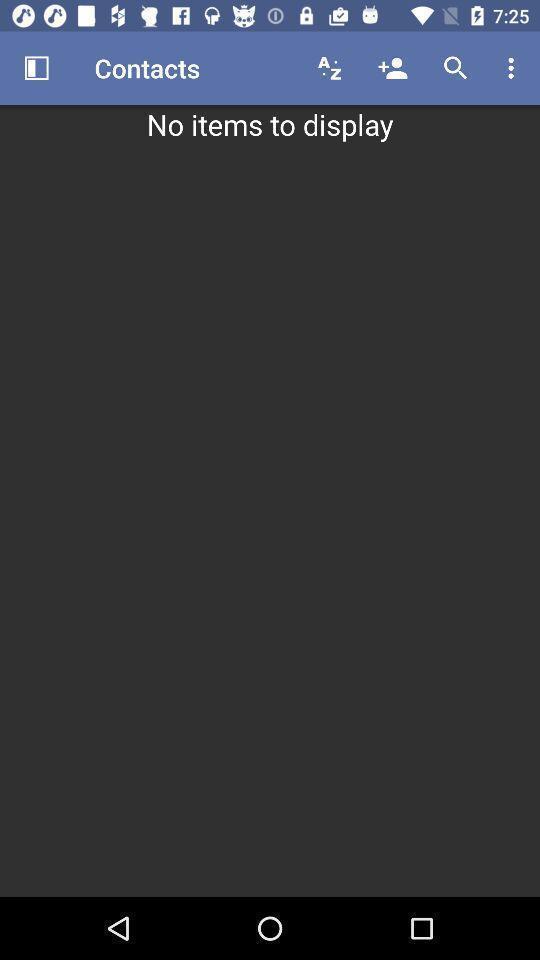Summarize the main components in this picture. Window displaying a contacts page. 